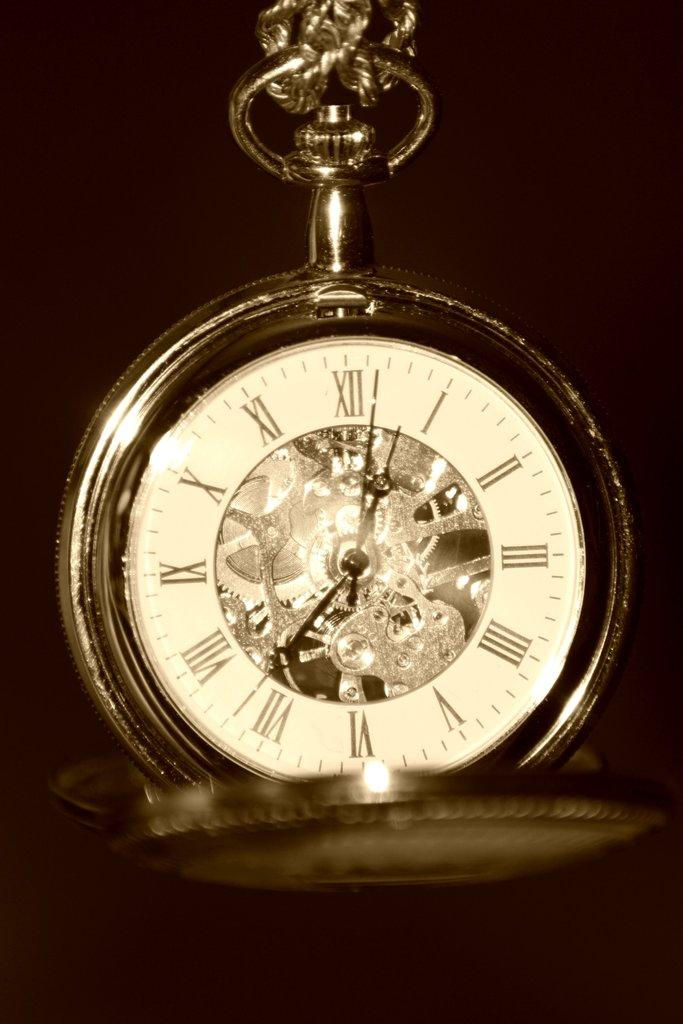<image>
Offer a succinct explanation of the picture presented. Clock that is in roman numerals that is sitting by itself. 